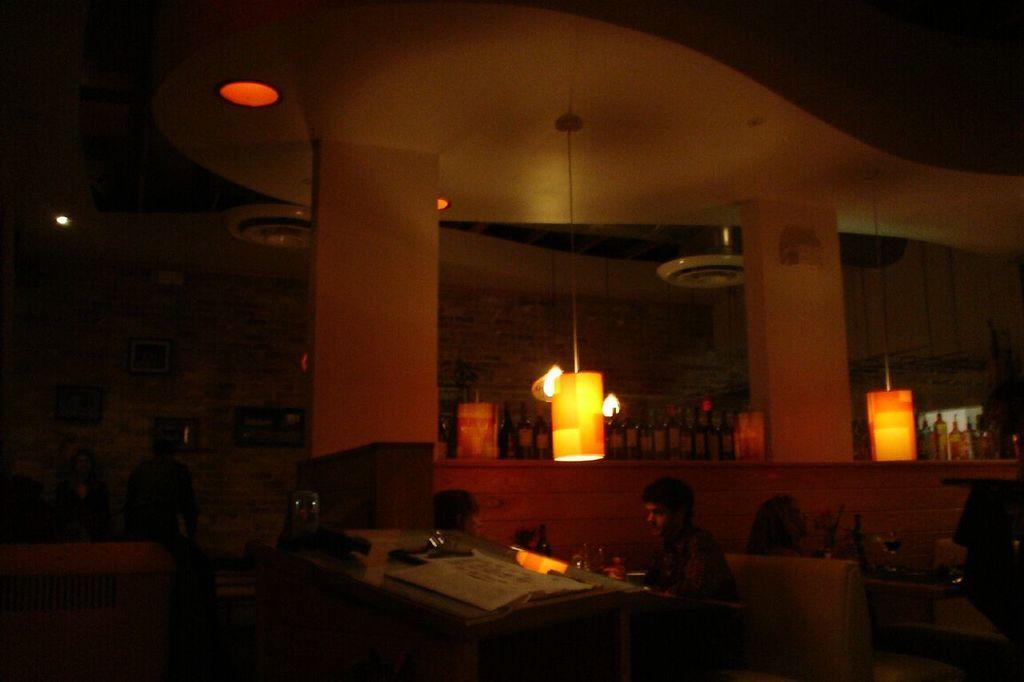Describe this image in one or two sentences. This picture describes about group of people, they are sweated, in the background we can see few lights and bottles in the racks, and also we can see a paper on the table. 